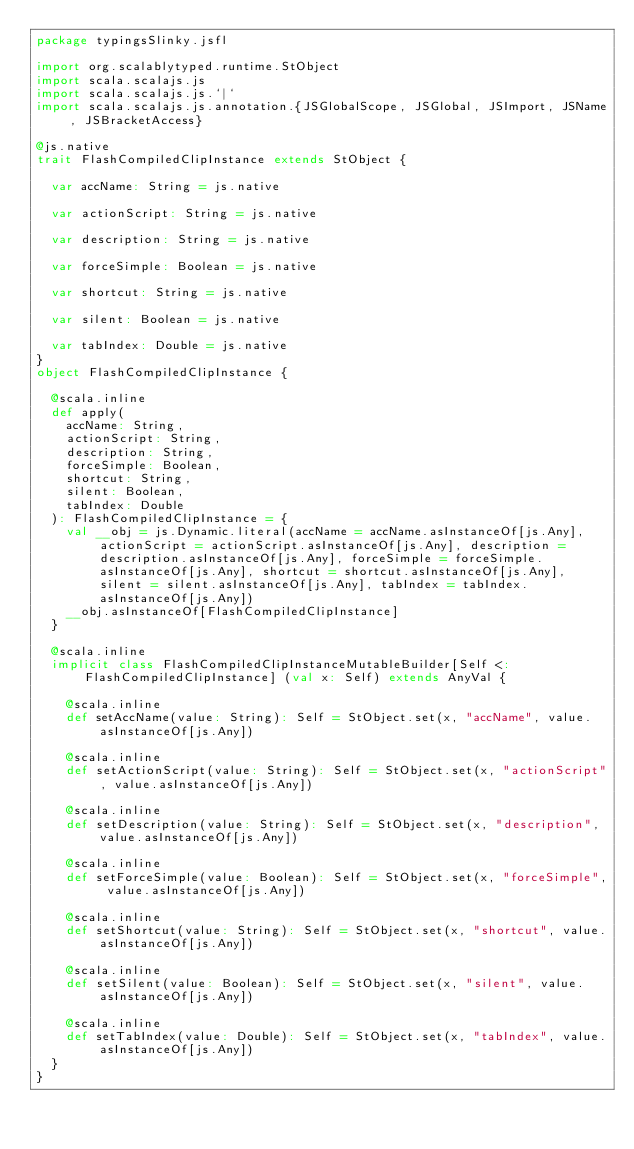Convert code to text. <code><loc_0><loc_0><loc_500><loc_500><_Scala_>package typingsSlinky.jsfl

import org.scalablytyped.runtime.StObject
import scala.scalajs.js
import scala.scalajs.js.`|`
import scala.scalajs.js.annotation.{JSGlobalScope, JSGlobal, JSImport, JSName, JSBracketAccess}

@js.native
trait FlashCompiledClipInstance extends StObject {
  
  var accName: String = js.native
  
  var actionScript: String = js.native
  
  var description: String = js.native
  
  var forceSimple: Boolean = js.native
  
  var shortcut: String = js.native
  
  var silent: Boolean = js.native
  
  var tabIndex: Double = js.native
}
object FlashCompiledClipInstance {
  
  @scala.inline
  def apply(
    accName: String,
    actionScript: String,
    description: String,
    forceSimple: Boolean,
    shortcut: String,
    silent: Boolean,
    tabIndex: Double
  ): FlashCompiledClipInstance = {
    val __obj = js.Dynamic.literal(accName = accName.asInstanceOf[js.Any], actionScript = actionScript.asInstanceOf[js.Any], description = description.asInstanceOf[js.Any], forceSimple = forceSimple.asInstanceOf[js.Any], shortcut = shortcut.asInstanceOf[js.Any], silent = silent.asInstanceOf[js.Any], tabIndex = tabIndex.asInstanceOf[js.Any])
    __obj.asInstanceOf[FlashCompiledClipInstance]
  }
  
  @scala.inline
  implicit class FlashCompiledClipInstanceMutableBuilder[Self <: FlashCompiledClipInstance] (val x: Self) extends AnyVal {
    
    @scala.inline
    def setAccName(value: String): Self = StObject.set(x, "accName", value.asInstanceOf[js.Any])
    
    @scala.inline
    def setActionScript(value: String): Self = StObject.set(x, "actionScript", value.asInstanceOf[js.Any])
    
    @scala.inline
    def setDescription(value: String): Self = StObject.set(x, "description", value.asInstanceOf[js.Any])
    
    @scala.inline
    def setForceSimple(value: Boolean): Self = StObject.set(x, "forceSimple", value.asInstanceOf[js.Any])
    
    @scala.inline
    def setShortcut(value: String): Self = StObject.set(x, "shortcut", value.asInstanceOf[js.Any])
    
    @scala.inline
    def setSilent(value: Boolean): Self = StObject.set(x, "silent", value.asInstanceOf[js.Any])
    
    @scala.inline
    def setTabIndex(value: Double): Self = StObject.set(x, "tabIndex", value.asInstanceOf[js.Any])
  }
}
</code> 